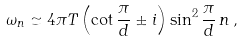Convert formula to latex. <formula><loc_0><loc_0><loc_500><loc_500>\omega _ { n } \simeq 4 \pi T \left ( \cot \frac { \pi } { d } \pm i \right ) \sin ^ { 2 } \frac { \pi } { d } \, n \, ,</formula> 